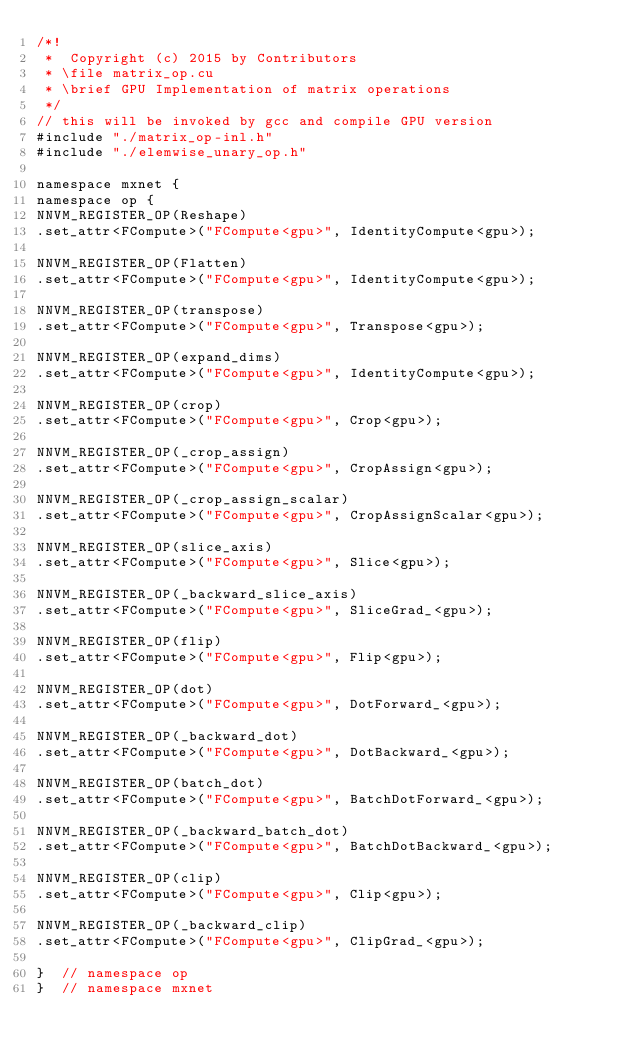Convert code to text. <code><loc_0><loc_0><loc_500><loc_500><_Cuda_>/*!
 *  Copyright (c) 2015 by Contributors
 * \file matrix_op.cu
 * \brief GPU Implementation of matrix operations
 */
// this will be invoked by gcc and compile GPU version
#include "./matrix_op-inl.h"
#include "./elemwise_unary_op.h"

namespace mxnet {
namespace op {
NNVM_REGISTER_OP(Reshape)
.set_attr<FCompute>("FCompute<gpu>", IdentityCompute<gpu>);

NNVM_REGISTER_OP(Flatten)
.set_attr<FCompute>("FCompute<gpu>", IdentityCompute<gpu>);

NNVM_REGISTER_OP(transpose)
.set_attr<FCompute>("FCompute<gpu>", Transpose<gpu>);

NNVM_REGISTER_OP(expand_dims)
.set_attr<FCompute>("FCompute<gpu>", IdentityCompute<gpu>);

NNVM_REGISTER_OP(crop)
.set_attr<FCompute>("FCompute<gpu>", Crop<gpu>);

NNVM_REGISTER_OP(_crop_assign)
.set_attr<FCompute>("FCompute<gpu>", CropAssign<gpu>);

NNVM_REGISTER_OP(_crop_assign_scalar)
.set_attr<FCompute>("FCompute<gpu>", CropAssignScalar<gpu>);

NNVM_REGISTER_OP(slice_axis)
.set_attr<FCompute>("FCompute<gpu>", Slice<gpu>);

NNVM_REGISTER_OP(_backward_slice_axis)
.set_attr<FCompute>("FCompute<gpu>", SliceGrad_<gpu>);

NNVM_REGISTER_OP(flip)
.set_attr<FCompute>("FCompute<gpu>", Flip<gpu>);

NNVM_REGISTER_OP(dot)
.set_attr<FCompute>("FCompute<gpu>", DotForward_<gpu>);

NNVM_REGISTER_OP(_backward_dot)
.set_attr<FCompute>("FCompute<gpu>", DotBackward_<gpu>);

NNVM_REGISTER_OP(batch_dot)
.set_attr<FCompute>("FCompute<gpu>", BatchDotForward_<gpu>);

NNVM_REGISTER_OP(_backward_batch_dot)
.set_attr<FCompute>("FCompute<gpu>", BatchDotBackward_<gpu>);

NNVM_REGISTER_OP(clip)
.set_attr<FCompute>("FCompute<gpu>", Clip<gpu>);

NNVM_REGISTER_OP(_backward_clip)
.set_attr<FCompute>("FCompute<gpu>", ClipGrad_<gpu>);

}  // namespace op
}  // namespace mxnet
</code> 